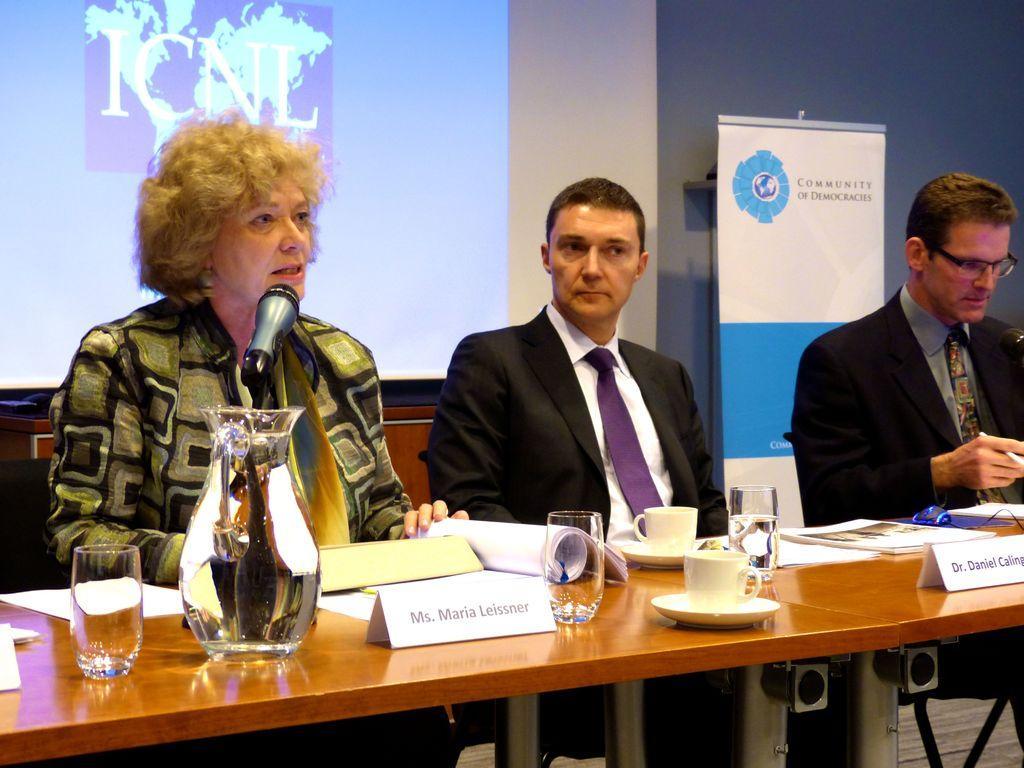Could you give a brief overview of what you see in this image? There are three people in the image. They are sitting on a chair. There is a table placed before them. There is a jug, a glass, papers a cup placed on a table. In the background there is a screen and a board. There is a mic placed before a lady. 